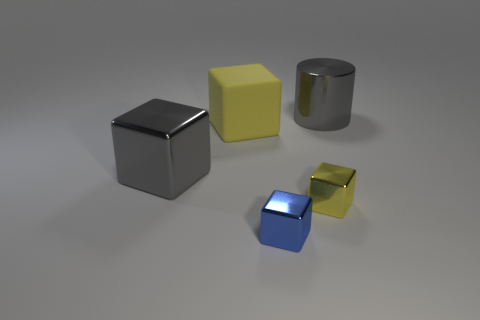Subtract 1 cubes. How many cubes are left? 3 Add 3 blue rubber balls. How many objects exist? 8 Subtract all cubes. How many objects are left? 1 Subtract all blue things. Subtract all metal blocks. How many objects are left? 1 Add 3 small yellow shiny cubes. How many small yellow shiny cubes are left? 4 Add 2 large gray objects. How many large gray objects exist? 4 Subtract 0 red spheres. How many objects are left? 5 